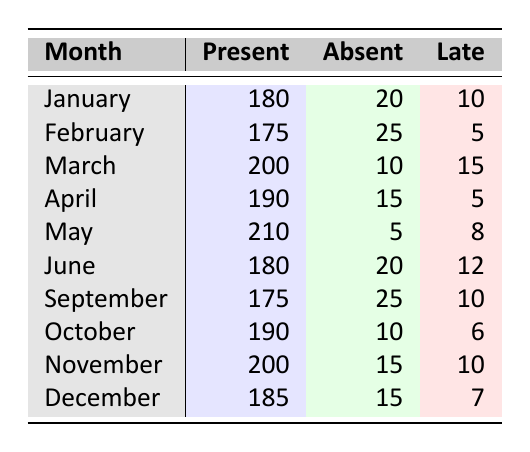What is the total number of students present in May? In May, the table shows 210 students present. There are no calculations needed since this is a direct retrieval from the table.
Answer: 210 What is the number of students absent in February? In February, the data states that 25 students were absent. This is a straightforward extraction from the table.
Answer: 25 Which month had the highest number of late students? By reviewing the late counts across all months, March has 15 late students, which is the highest compared to all other months. This requires comparing the "Late" column values.
Answer: March What is the average number of students absent per month? To find the average, sum the absent values for all months (20 + 25 + 10 + 15 + 5 + 20 + 25 + 10 + 15 + 15 =  155) and divide by the number of months (10). The calculation gives an average of 15.5 absent students.
Answer: 15.5 Did more students attend in November than in January? In January, there were 180 students present, and in November, there were 200 present. Since 200 is greater than 180, the statement is true.
Answer: Yes Which month had the least number of students late? By examining the "Late" column, February has the least number at 5. This is a direct retrieval of the values in that column.
Answer: February What is the total number of students (present, absent, and late) in March? The total in March can be found by adding all three categories: 200 (present) + 10 (absent) + 15 (late) = 225. This aggregates all the data points for that month.
Answer: 225 Compare the total presents in June and September. Were they equal? The attendance data shows 180 in June and 175 in September. Since they are not equal—180 is not equal to 175—the answer is no.
Answer: No What is the difference between the number of students present in May and April? To find the difference, subtract the April total (190) from May (210). This yields 210 - 190 = 20, indicating that May had 20 more students present than April.
Answer: 20 What was the total number of absences recorded from January to December? To find the total absences, sum the absent counts (20 + 25 + 10 + 15 + 5 + 20 + 25 + 10 + 15 + 15 = 155). This adds all values from the "Absent" column.
Answer: 155 